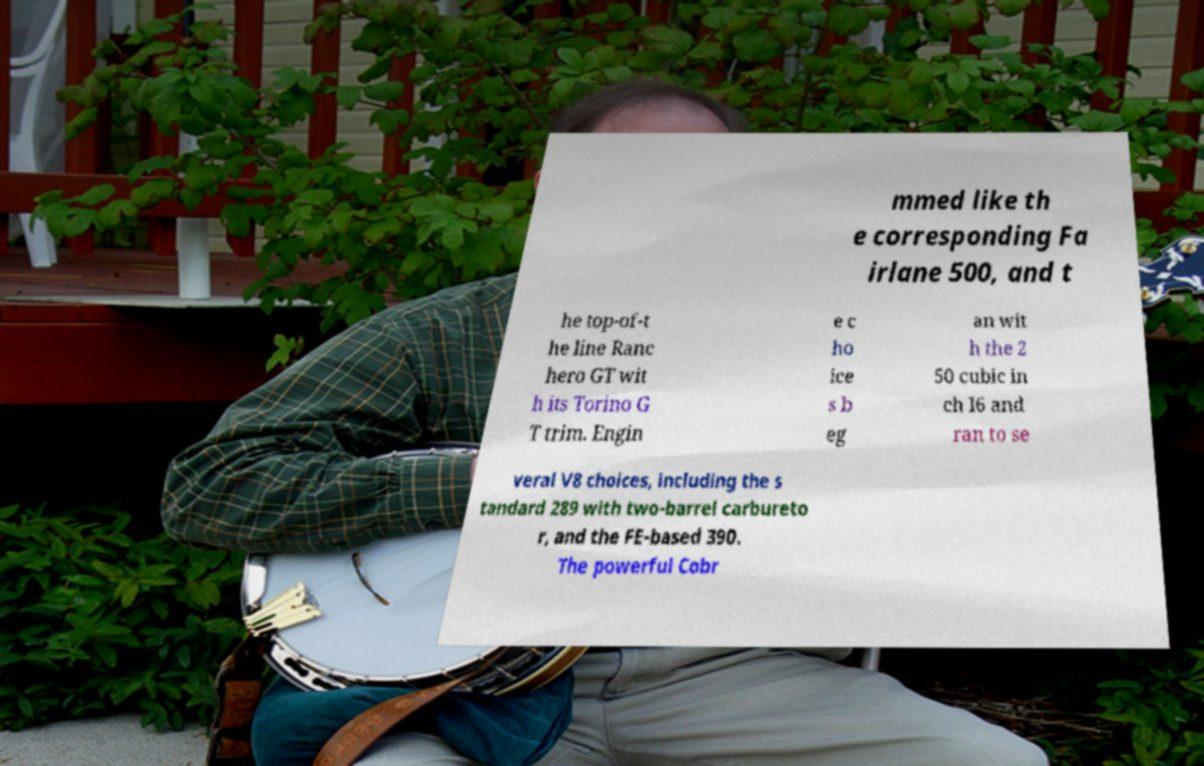Can you read and provide the text displayed in the image?This photo seems to have some interesting text. Can you extract and type it out for me? mmed like th e corresponding Fa irlane 500, and t he top-of-t he line Ranc hero GT wit h its Torino G T trim. Engin e c ho ice s b eg an wit h the 2 50 cubic in ch I6 and ran to se veral V8 choices, including the s tandard 289 with two-barrel carbureto r, and the FE-based 390. The powerful Cobr 